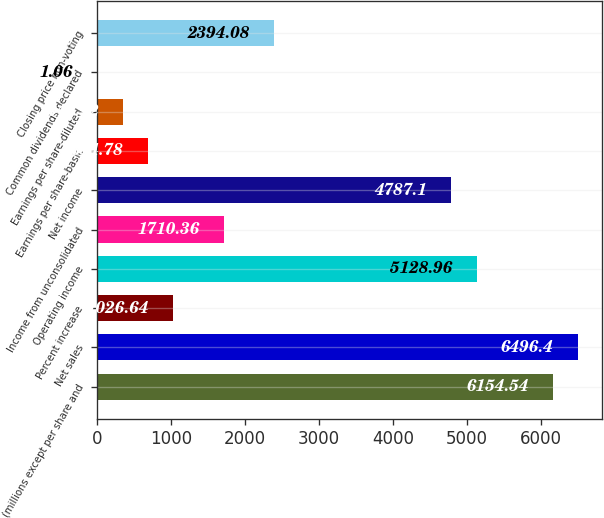<chart> <loc_0><loc_0><loc_500><loc_500><bar_chart><fcel>(millions except per share and<fcel>Net sales<fcel>Percent increase<fcel>Operating income<fcel>Income from unconsolidated<fcel>Net income<fcel>Earnings per share-basic<fcel>Earnings per share-diluted<fcel>Common dividends declared<fcel>Closing price non-voting<nl><fcel>6154.54<fcel>6496.4<fcel>1026.64<fcel>5128.96<fcel>1710.36<fcel>4787.1<fcel>684.78<fcel>342.92<fcel>1.06<fcel>2394.08<nl></chart> 